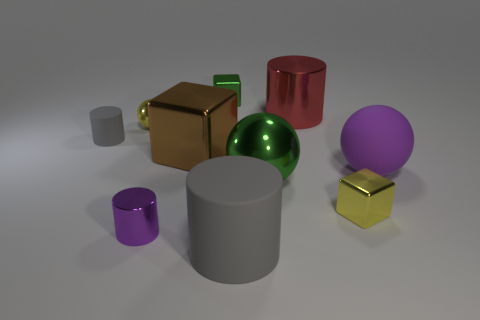How many matte things are tiny red objects or green things?
Make the answer very short. 0. Are there any green matte cylinders?
Keep it short and to the point. No. Is the large red metal object the same shape as the small green metallic thing?
Give a very brief answer. No. There is a metal cylinder that is on the left side of the tiny shiny block on the left side of the yellow metal cube; what number of gray rubber cylinders are behind it?
Ensure brevity in your answer.  1. The cylinder that is behind the tiny purple object and left of the green metal block is made of what material?
Your answer should be very brief. Rubber. What color is the large thing that is in front of the red shiny thing and on the right side of the big green metallic object?
Provide a short and direct response. Purple. Are there any other things of the same color as the big shiny cylinder?
Your answer should be compact. No. What is the shape of the purple object on the right side of the large thing in front of the purple object that is on the left side of the green shiny cube?
Provide a short and direct response. Sphere. The other tiny object that is the same shape as the tiny gray matte object is what color?
Your answer should be compact. Purple. The tiny block that is in front of the metal cube behind the red object is what color?
Your response must be concise. Yellow. 